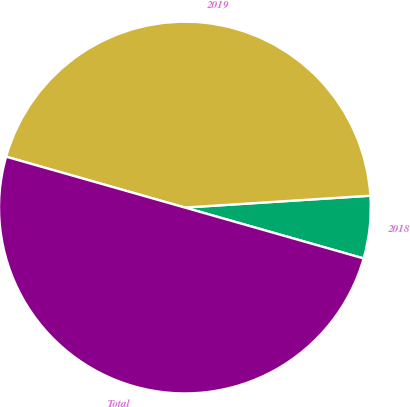<chart> <loc_0><loc_0><loc_500><loc_500><pie_chart><fcel>2018<fcel>2019<fcel>Total<nl><fcel>5.43%<fcel>44.57%<fcel>50.0%<nl></chart> 